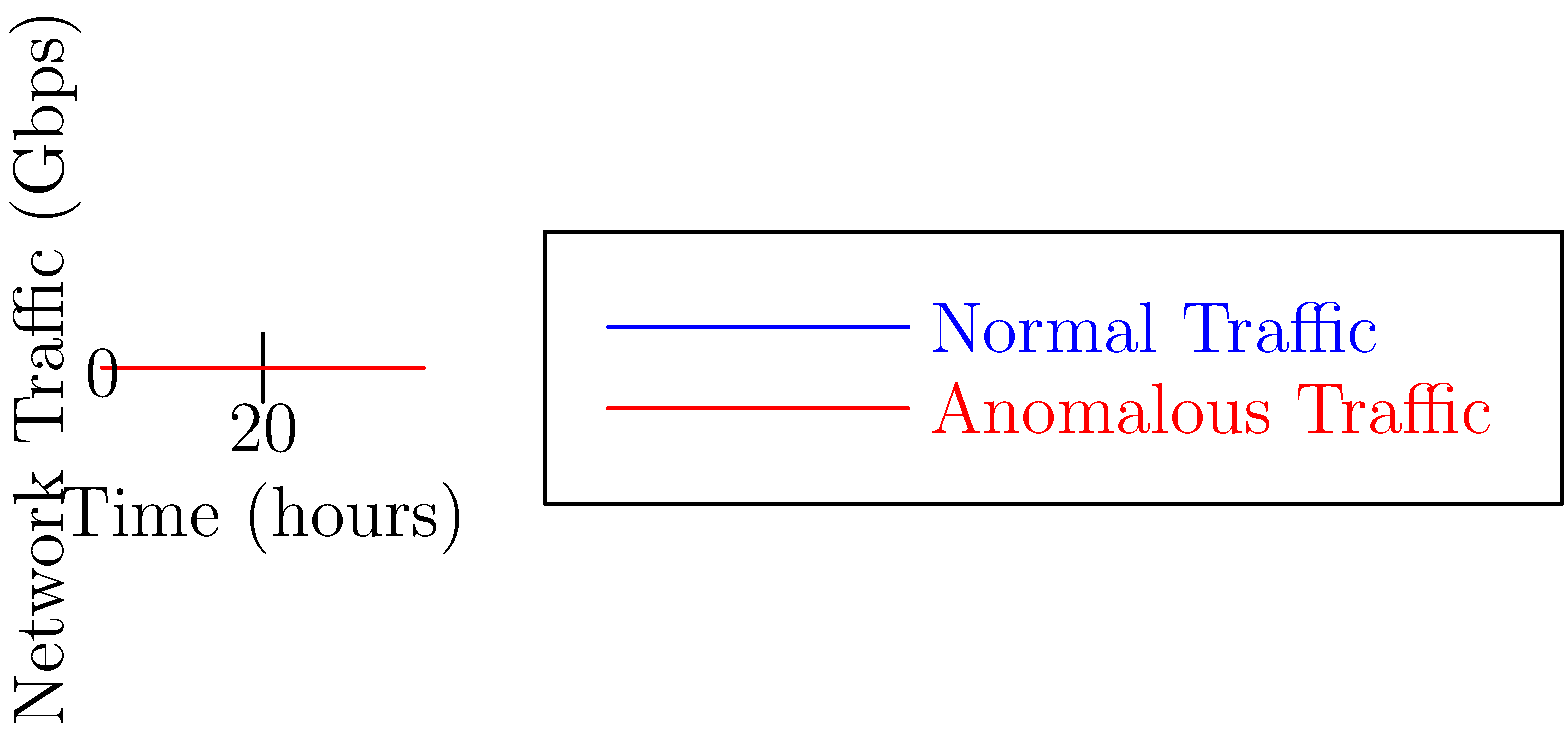As a former pilot now working in network security, you're analyzing traffic patterns for potential cyber threats. The graph shows normal and anomalous network traffic over a 6-hour period. What is the maximum difference in traffic volume between normal and anomalous patterns, and at which hour does it occur? To solve this problem, we need to follow these steps:

1. Analyze the two lines on the graph:
   - Blue line represents normal traffic
   - Red line represents anomalous traffic

2. Calculate the difference between normal and anomalous traffic for each hour:
   Hour 1: 10 - 5 = 5 Gbps
   Hour 2: 15 - 10 = 5 Gbps
   Hour 3: 25 - 20 = 5 Gbps
   Hour 4: 30 - 35 = -5 Gbps
   Hour 5: 20 - 25 = -5 Gbps
   Hour 6: 10 - 15 = -5 Gbps

3. Identify the maximum absolute difference:
   The maximum absolute difference is 5 Gbps, which occurs at multiple hours.

4. Determine at which hour the maximum difference first occurs:
   The maximum difference of 5 Gbps first occurs at hour 1.

Therefore, the maximum difference in traffic volume between normal and anomalous patterns is 5 Gbps, and it first occurs at hour 1.
Answer: 5 Gbps at hour 1 